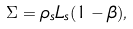<formula> <loc_0><loc_0><loc_500><loc_500>\Sigma = \rho _ { s } L _ { s } ( 1 - \beta ) ,</formula> 